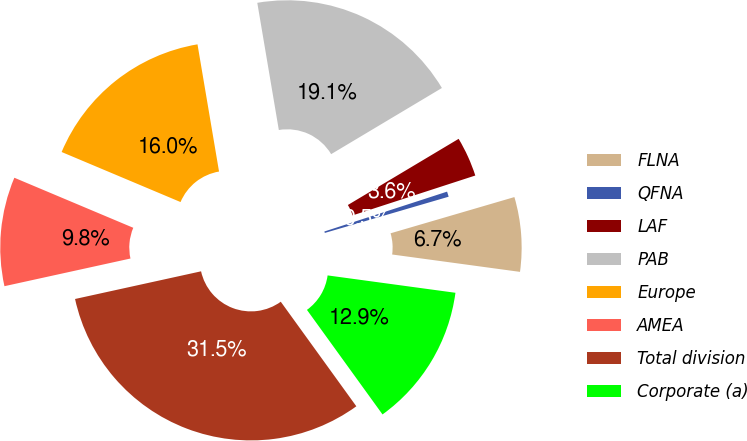Convert chart to OTSL. <chart><loc_0><loc_0><loc_500><loc_500><pie_chart><fcel>FLNA<fcel>QFNA<fcel>LAF<fcel>PAB<fcel>Europe<fcel>AMEA<fcel>Total division<fcel>Corporate (a)<nl><fcel>6.68%<fcel>0.47%<fcel>3.57%<fcel>19.1%<fcel>15.99%<fcel>9.78%<fcel>31.52%<fcel>12.89%<nl></chart> 